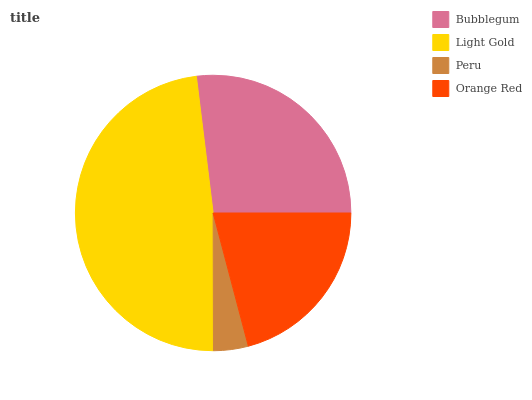Is Peru the minimum?
Answer yes or no. Yes. Is Light Gold the maximum?
Answer yes or no. Yes. Is Light Gold the minimum?
Answer yes or no. No. Is Peru the maximum?
Answer yes or no. No. Is Light Gold greater than Peru?
Answer yes or no. Yes. Is Peru less than Light Gold?
Answer yes or no. Yes. Is Peru greater than Light Gold?
Answer yes or no. No. Is Light Gold less than Peru?
Answer yes or no. No. Is Bubblegum the high median?
Answer yes or no. Yes. Is Orange Red the low median?
Answer yes or no. Yes. Is Orange Red the high median?
Answer yes or no. No. Is Light Gold the low median?
Answer yes or no. No. 